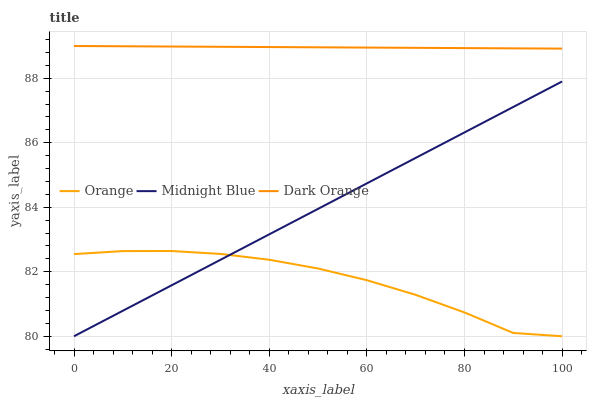Does Midnight Blue have the minimum area under the curve?
Answer yes or no. No. Does Midnight Blue have the maximum area under the curve?
Answer yes or no. No. Is Dark Orange the smoothest?
Answer yes or no. No. Is Dark Orange the roughest?
Answer yes or no. No. Does Dark Orange have the lowest value?
Answer yes or no. No. Does Midnight Blue have the highest value?
Answer yes or no. No. Is Orange less than Dark Orange?
Answer yes or no. Yes. Is Dark Orange greater than Midnight Blue?
Answer yes or no. Yes. Does Orange intersect Dark Orange?
Answer yes or no. No. 